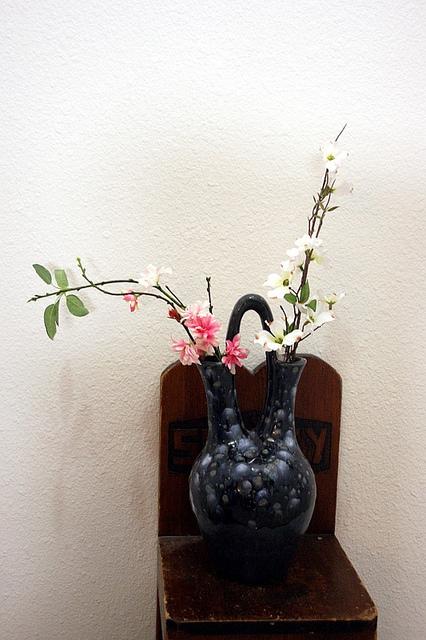What is the material of the vase?
Answer briefly. Glass. How many openings does the vase have?
Be succinct. 2. What two colors are the flowers in the vase?
Answer briefly. Pink and white. 